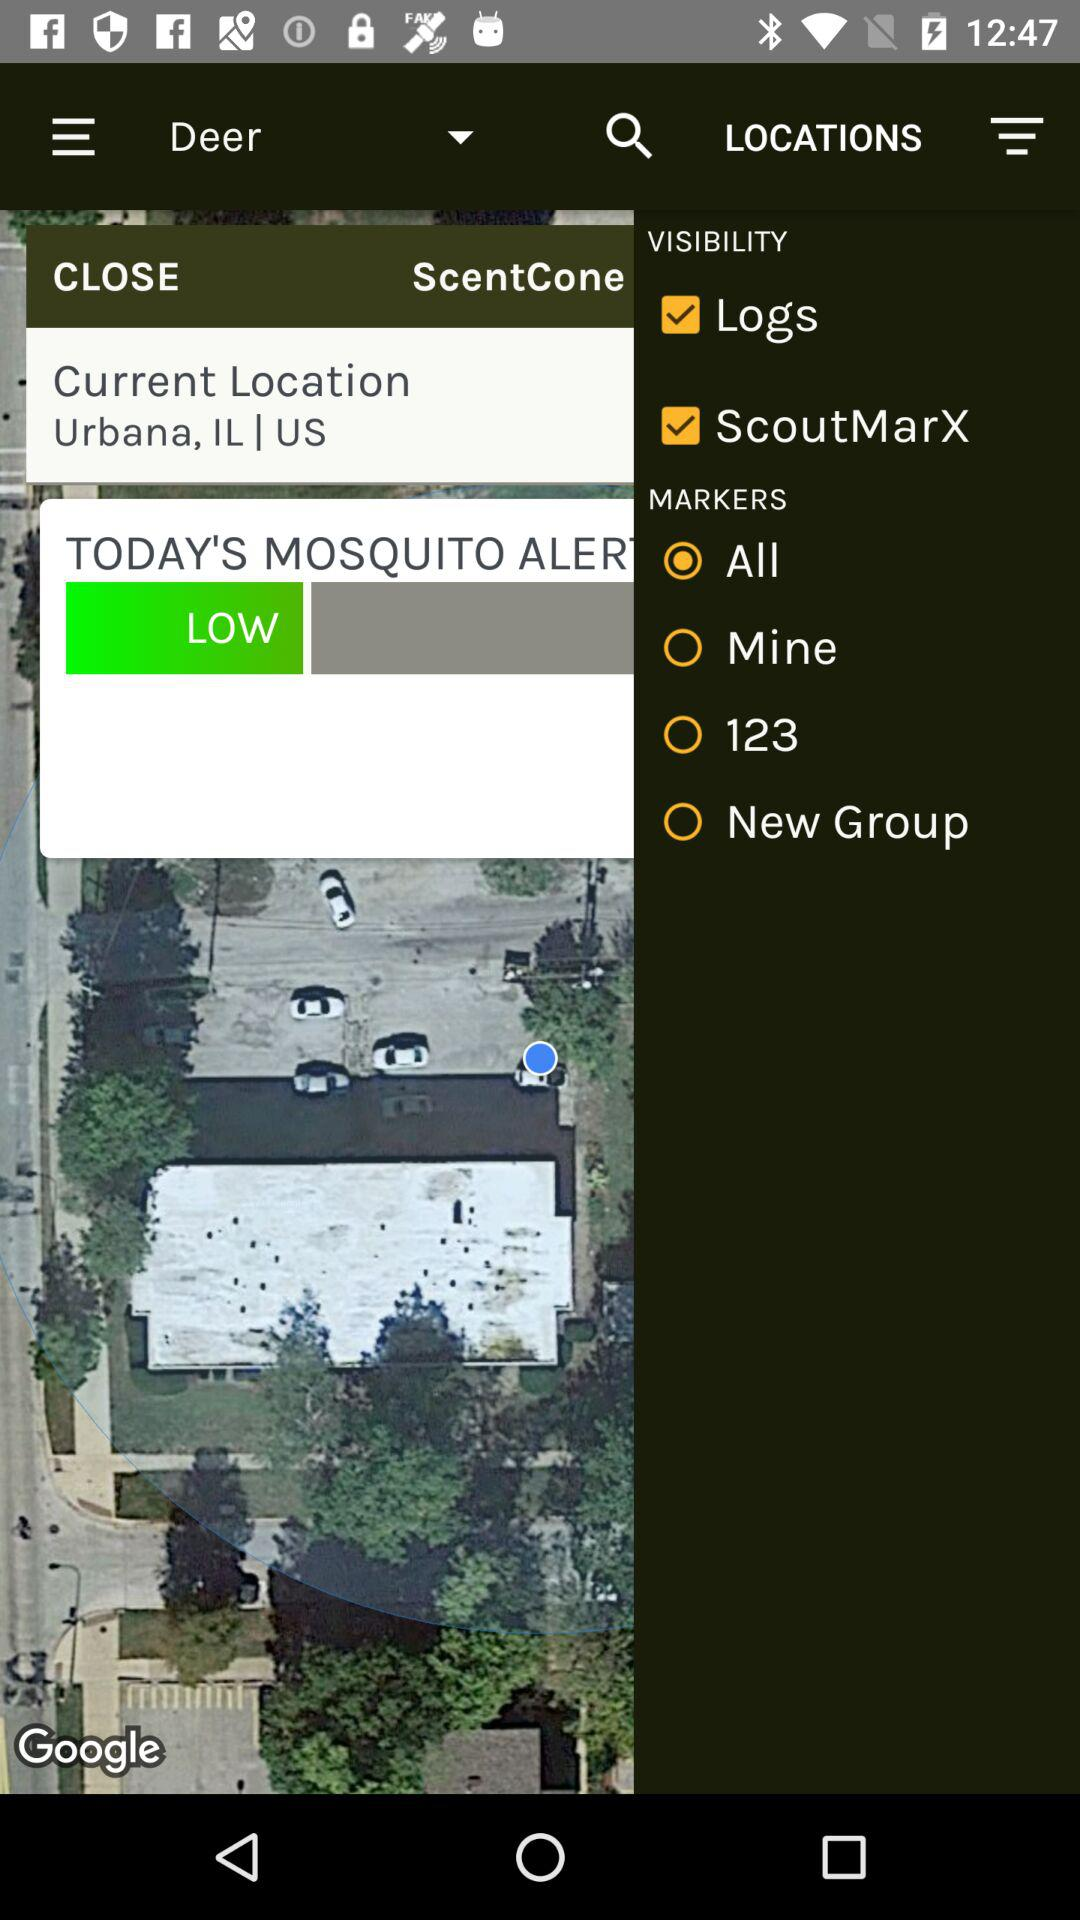Which are the different marker options? The different marker options are All, Mine, 123, and New Group. 